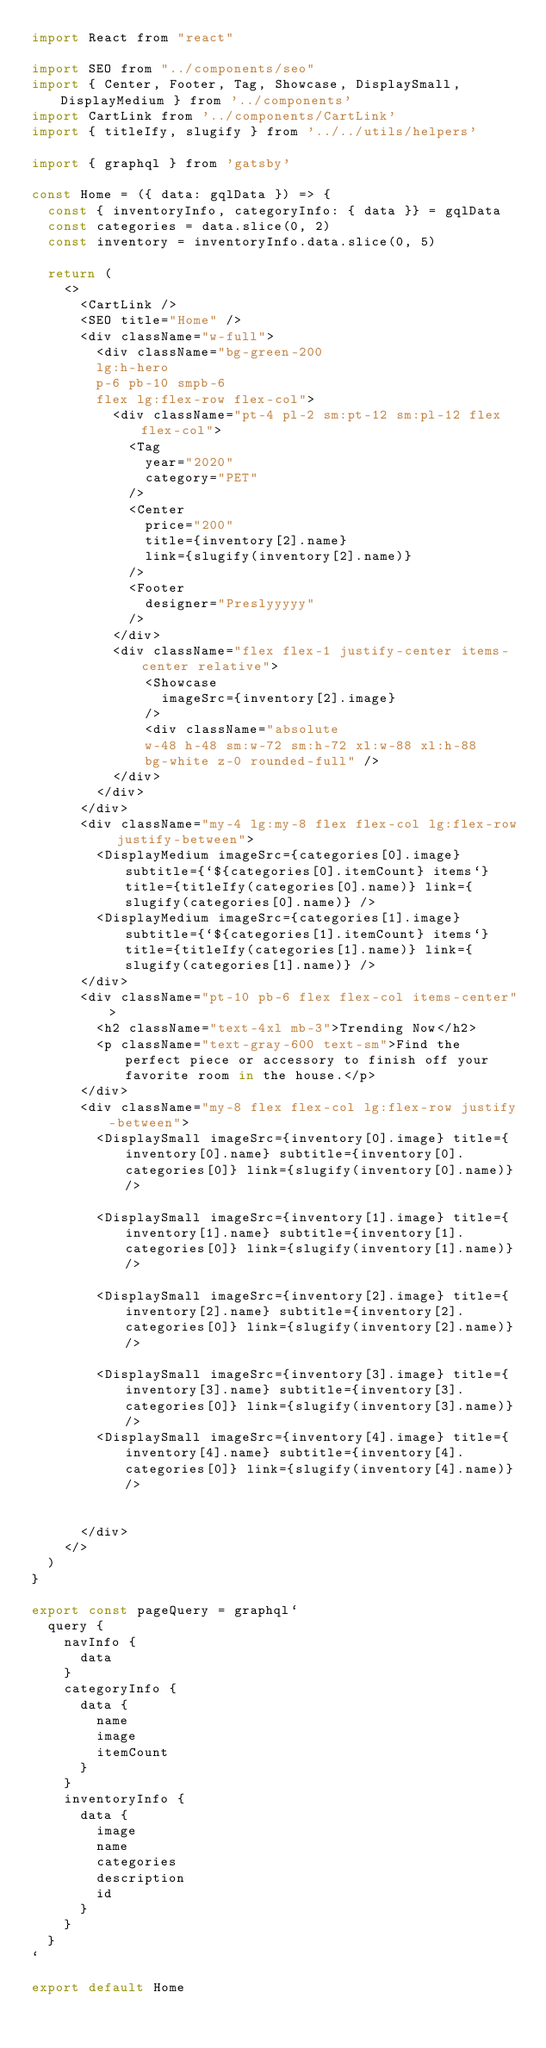Convert code to text. <code><loc_0><loc_0><loc_500><loc_500><_JavaScript_>import React from "react"

import SEO from "../components/seo"
import { Center, Footer, Tag, Showcase, DisplaySmall, DisplayMedium } from '../components'
import CartLink from '../components/CartLink'
import { titleIfy, slugify } from '../../utils/helpers'

import { graphql } from 'gatsby'

const Home = ({ data: gqlData }) => {
  const { inventoryInfo, categoryInfo: { data }} = gqlData
  const categories = data.slice(0, 2)
  const inventory = inventoryInfo.data.slice(0, 5)

  return (
    <>
      <CartLink />
      <SEO title="Home" />
      <div className="w-full">
        <div className="bg-green-200
        lg:h-hero
        p-6 pb-10 smpb-6
        flex lg:flex-row flex-col">
          <div className="pt-4 pl-2 sm:pt-12 sm:pl-12 flex flex-col">
            <Tag
              year="2020"
              category="PET"
            />
            <Center
              price="200"
              title={inventory[2].name}
              link={slugify(inventory[2].name)}
            />
            <Footer
              designer="Preslyyyyy"
            />
          </div>
          <div className="flex flex-1 justify-center items-center relative">
              <Showcase
                imageSrc={inventory[2].image}
              />
              <div className="absolute
              w-48 h-48 sm:w-72 sm:h-72 xl:w-88 xl:h-88
              bg-white z-0 rounded-full" />
          </div>
        </div>
      </div>
      <div className="my-4 lg:my-8 flex flex-col lg:flex-row justify-between">
        <DisplayMedium imageSrc={categories[0].image} subtitle={`${categories[0].itemCount} items`} title={titleIfy(categories[0].name)} link={slugify(categories[0].name)} />
        <DisplayMedium imageSrc={categories[1].image} subtitle={`${categories[1].itemCount} items`} title={titleIfy(categories[1].name)} link={slugify(categories[1].name)} />
      </div>
      <div className="pt-10 pb-6 flex flex-col items-center">
        <h2 className="text-4xl mb-3">Trending Now</h2>
        <p className="text-gray-600 text-sm">Find the perfect piece or accessory to finish off your favorite room in the house.</p>
      </div>
      <div className="my-8 flex flex-col lg:flex-row justify-between">
        <DisplaySmall imageSrc={inventory[0].image} title={inventory[0].name} subtitle={inventory[0].categories[0]} link={slugify(inventory[0].name)} />

        <DisplaySmall imageSrc={inventory[1].image} title={inventory[1].name} subtitle={inventory[1].categories[0]} link={slugify(inventory[1].name)} />

        <DisplaySmall imageSrc={inventory[2].image} title={inventory[2].name} subtitle={inventory[2].categories[0]} link={slugify(inventory[2].name)} />

        <DisplaySmall imageSrc={inventory[3].image} title={inventory[3].name} subtitle={inventory[3].categories[0]} link={slugify(inventory[3].name)} />
        <DisplaySmall imageSrc={inventory[4].image} title={inventory[4].name} subtitle={inventory[4].categories[0]} link={slugify(inventory[4].name)} />


      </div>
    </>
  )
}

export const pageQuery = graphql`
  query {
    navInfo {
      data
    }
    categoryInfo {
      data {
        name
        image
        itemCount
      }
    }
    inventoryInfo {
      data {
        image
        name
        categories
        description
        id
      }
    }
  }
`

export default Home
</code> 